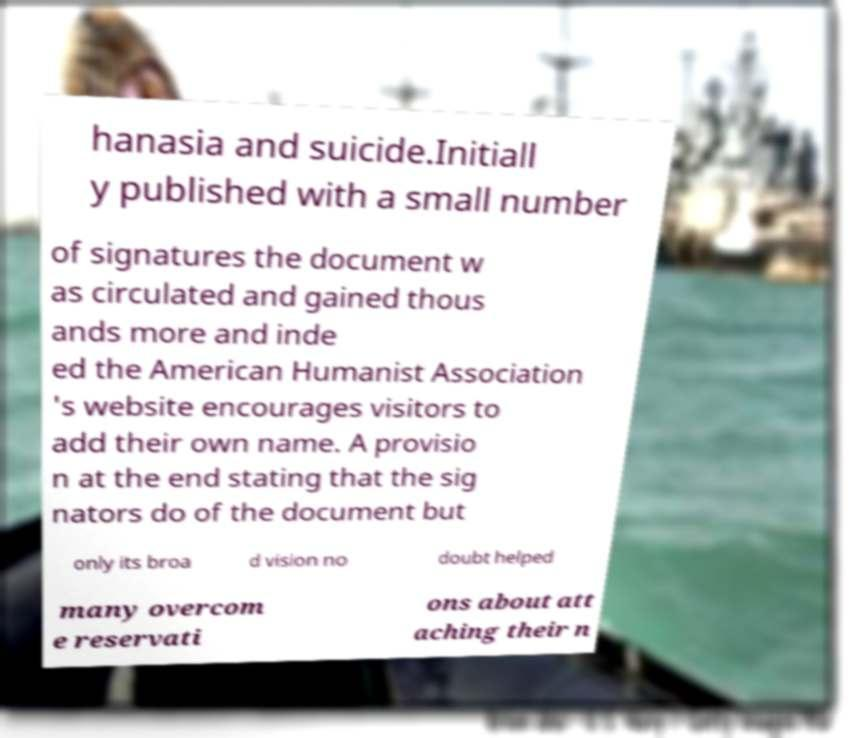What messages or text are displayed in this image? I need them in a readable, typed format. hanasia and suicide.Initiall y published with a small number of signatures the document w as circulated and gained thous ands more and inde ed the American Humanist Association 's website encourages visitors to add their own name. A provisio n at the end stating that the sig nators do of the document but only its broa d vision no doubt helped many overcom e reservati ons about att aching their n 